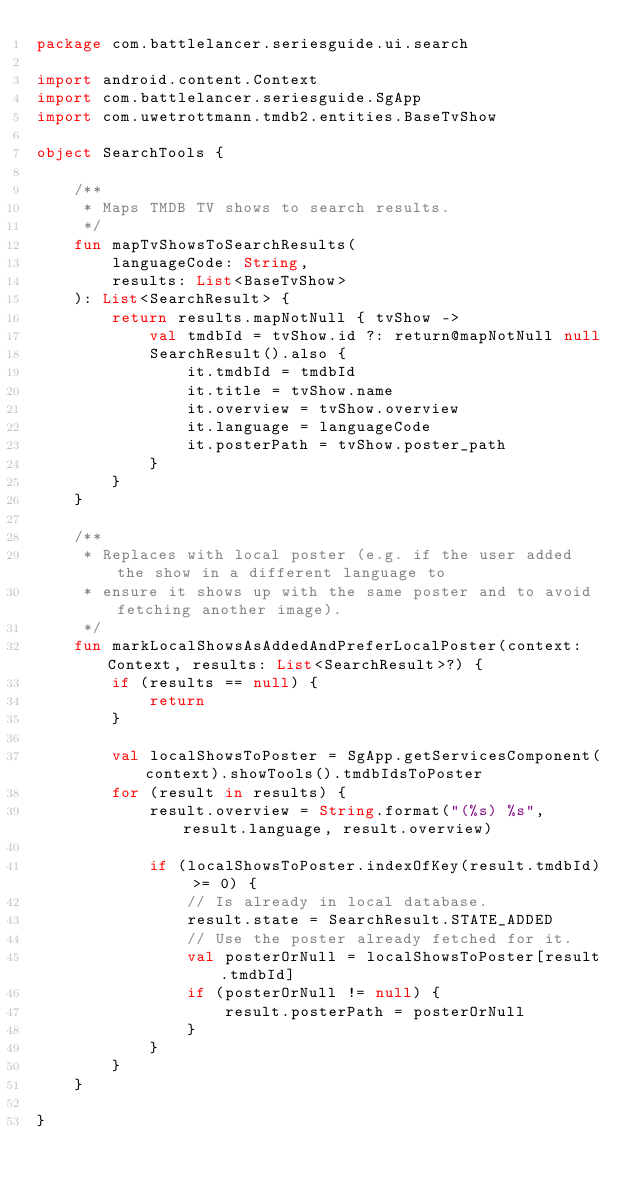<code> <loc_0><loc_0><loc_500><loc_500><_Kotlin_>package com.battlelancer.seriesguide.ui.search

import android.content.Context
import com.battlelancer.seriesguide.SgApp
import com.uwetrottmann.tmdb2.entities.BaseTvShow

object SearchTools {

    /**
     * Maps TMDB TV shows to search results.
     */
    fun mapTvShowsToSearchResults(
        languageCode: String,
        results: List<BaseTvShow>
    ): List<SearchResult> {
        return results.mapNotNull { tvShow ->
            val tmdbId = tvShow.id ?: return@mapNotNull null
            SearchResult().also {
                it.tmdbId = tmdbId
                it.title = tvShow.name
                it.overview = tvShow.overview
                it.language = languageCode
                it.posterPath = tvShow.poster_path
            }
        }
    }

    /**
     * Replaces with local poster (e.g. if the user added the show in a different language to
     * ensure it shows up with the same poster and to avoid fetching another image).
     */
    fun markLocalShowsAsAddedAndPreferLocalPoster(context: Context, results: List<SearchResult>?) {
        if (results == null) {
            return
        }

        val localShowsToPoster = SgApp.getServicesComponent(context).showTools().tmdbIdsToPoster
        for (result in results) {
            result.overview = String.format("(%s) %s", result.language, result.overview)

            if (localShowsToPoster.indexOfKey(result.tmdbId) >= 0) {
                // Is already in local database.
                result.state = SearchResult.STATE_ADDED
                // Use the poster already fetched for it.
                val posterOrNull = localShowsToPoster[result.tmdbId]
                if (posterOrNull != null) {
                    result.posterPath = posterOrNull
                }
            }
        }
    }

}</code> 